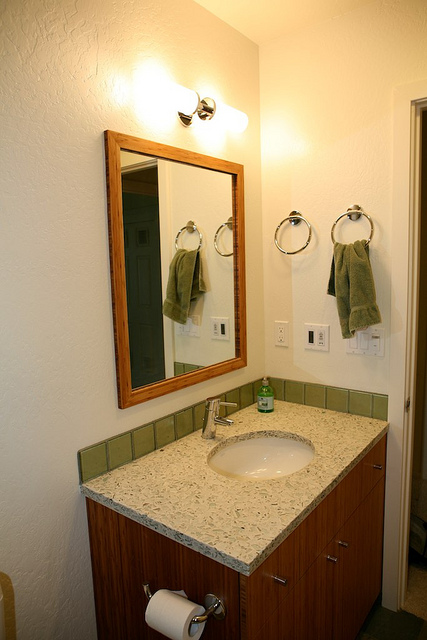<image>What type of wallpaper is here? It is ambiguous what type of wallpaper is here. It could be white, textured, or none. What is cast? I am not sure. It can either be a shadow, light or nothing. What type of wallpaper is here? It is unanswerable what type of wallpaper is here. What is cast? I am not sure what the cast is in the image. It can be a sink, shadow, light, or reflection. 